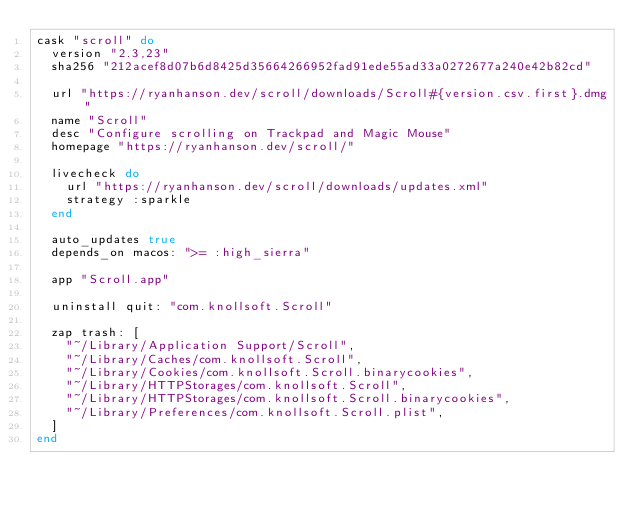<code> <loc_0><loc_0><loc_500><loc_500><_Ruby_>cask "scroll" do
  version "2.3,23"
  sha256 "212acef8d07b6d8425d35664266952fad91ede55ad33a0272677a240e42b82cd"

  url "https://ryanhanson.dev/scroll/downloads/Scroll#{version.csv.first}.dmg"
  name "Scroll"
  desc "Configure scrolling on Trackpad and Magic Mouse"
  homepage "https://ryanhanson.dev/scroll/"

  livecheck do
    url "https://ryanhanson.dev/scroll/downloads/updates.xml"
    strategy :sparkle
  end

  auto_updates true
  depends_on macos: ">= :high_sierra"

  app "Scroll.app"

  uninstall quit: "com.knollsoft.Scroll"

  zap trash: [
    "~/Library/Application Support/Scroll",
    "~/Library/Caches/com.knollsoft.Scroll",
    "~/Library/Cookies/com.knollsoft.Scroll.binarycookies",
    "~/Library/HTTPStorages/com.knollsoft.Scroll",
    "~/Library/HTTPStorages/com.knollsoft.Scroll.binarycookies",
    "~/Library/Preferences/com.knollsoft.Scroll.plist",
  ]
end
</code> 